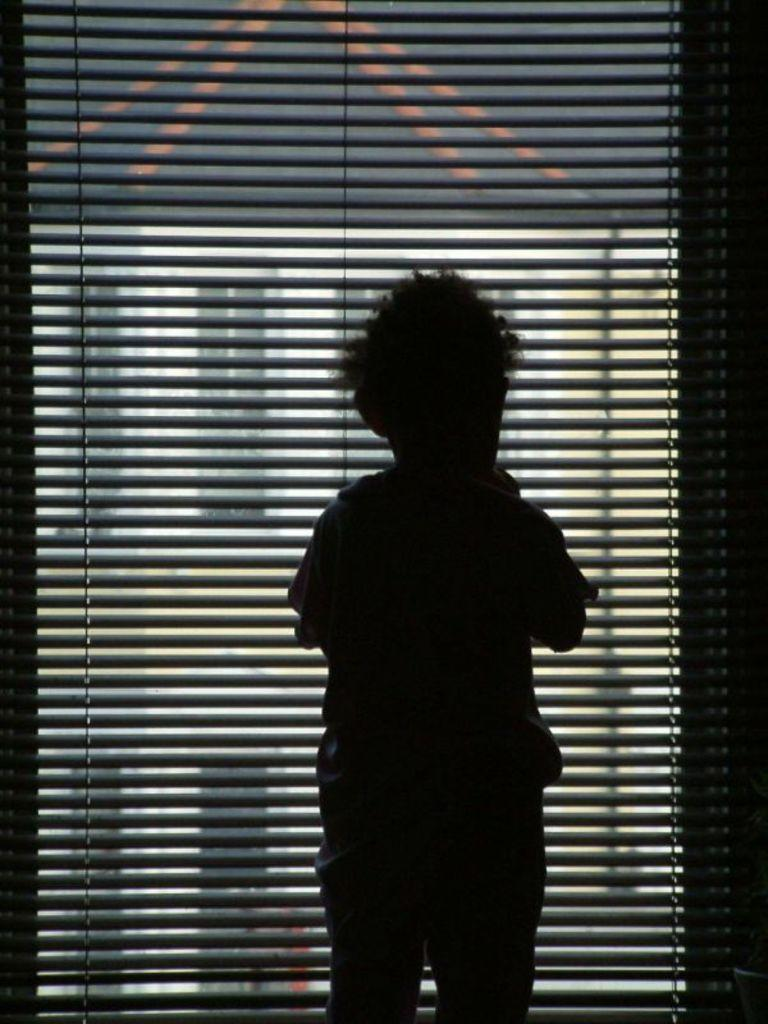What is the main subject of the image? There is a boy standing in the image. Can you describe the background of the image? There are window blinds in the background of the image. What type of punishment is the boy receiving in the image? There is no indication of punishment in the image; it simply shows a boy standing. What record is the boy attempting to break in the image? There is no record-breaking activity depicted in the image; it only shows a boy standing. 